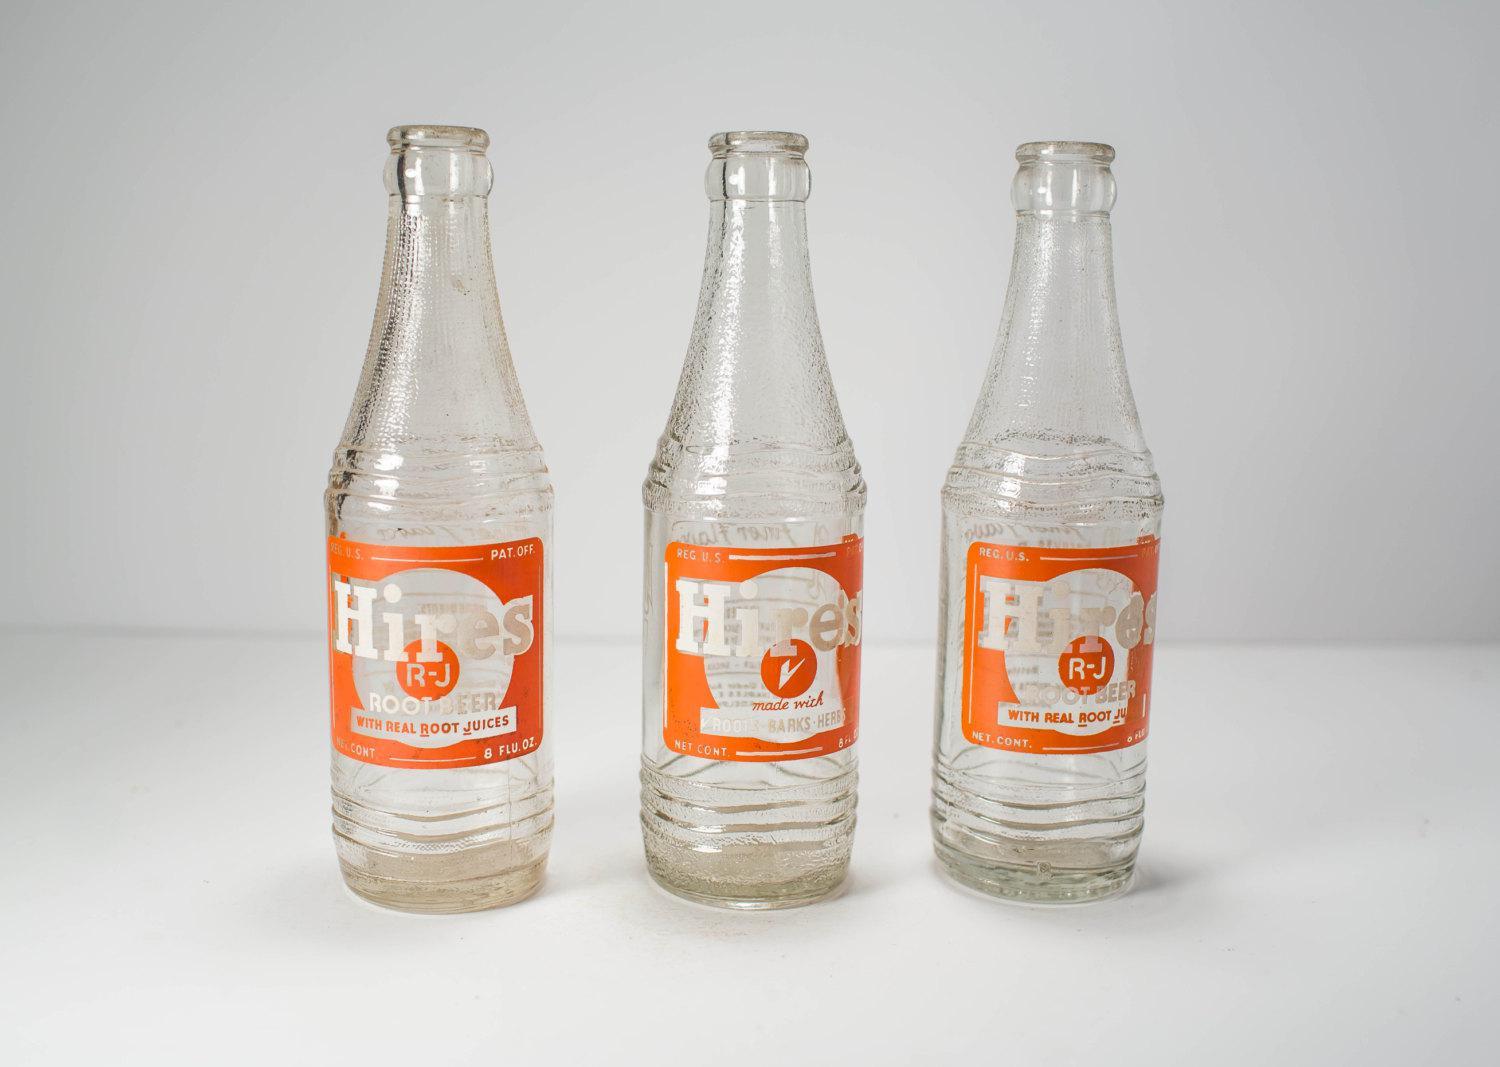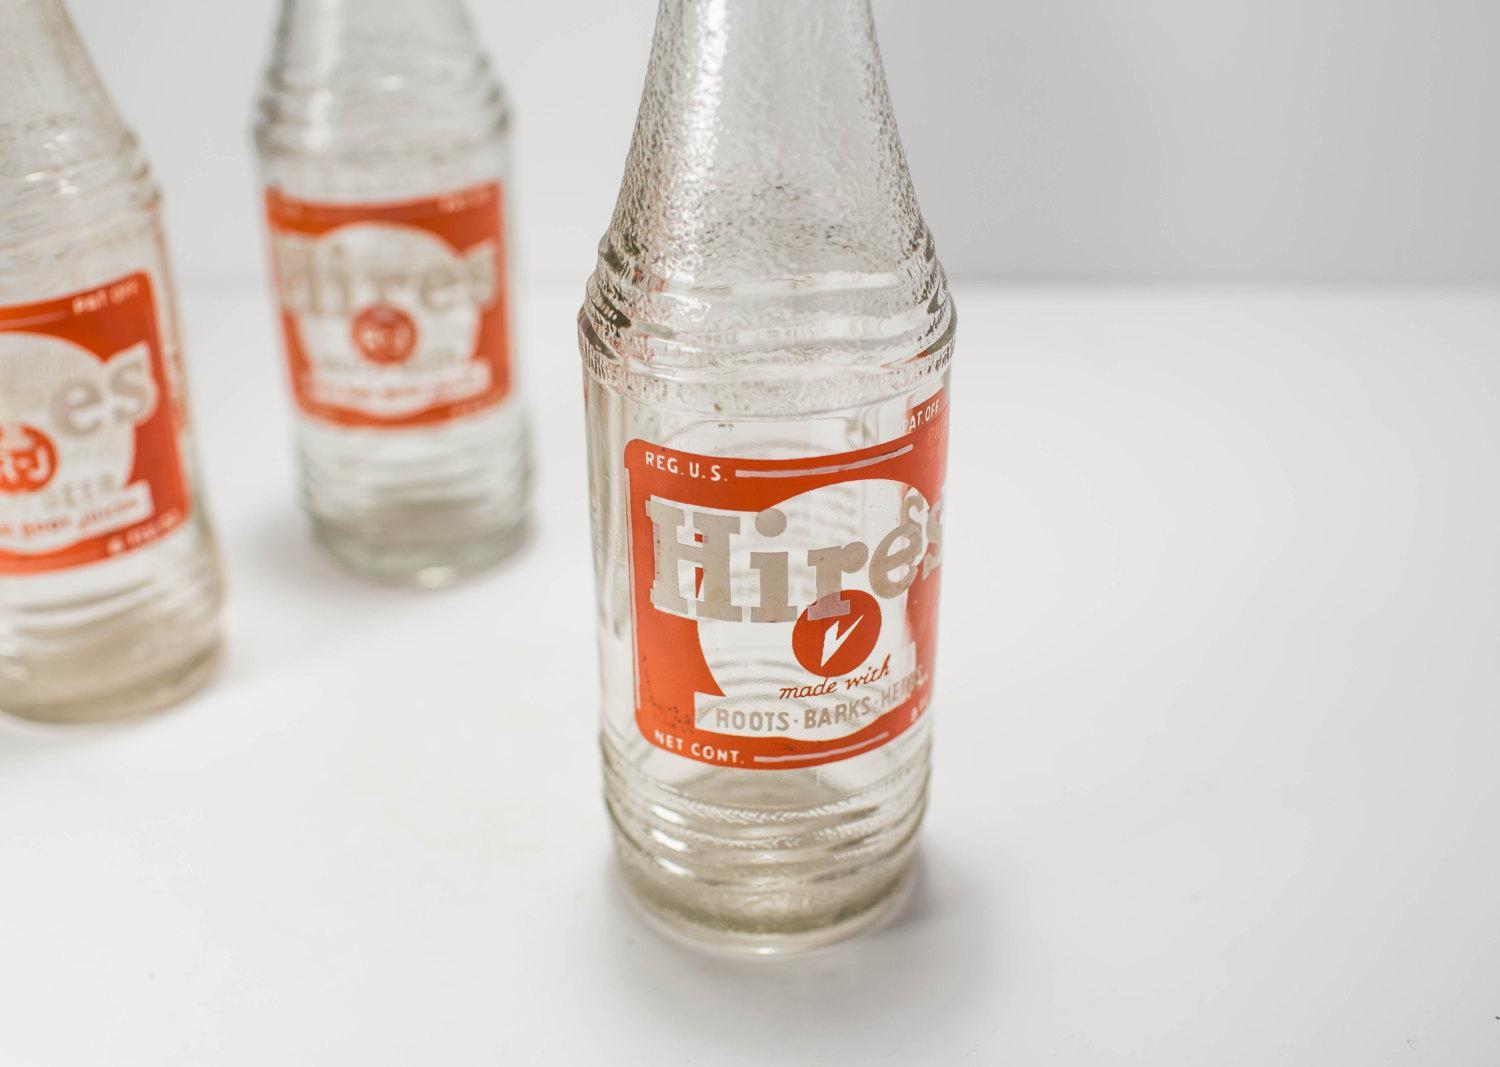The first image is the image on the left, the second image is the image on the right. Examine the images to the left and right. Is the description "There are fewer than six bottles in total." accurate? Answer yes or no. No. The first image is the image on the left, the second image is the image on the right. Assess this claim about the two images: "Each image contains three empty glass soda bottles, and at least one image features bottles with orange labels facing forward.". Correct or not? Answer yes or no. Yes. 